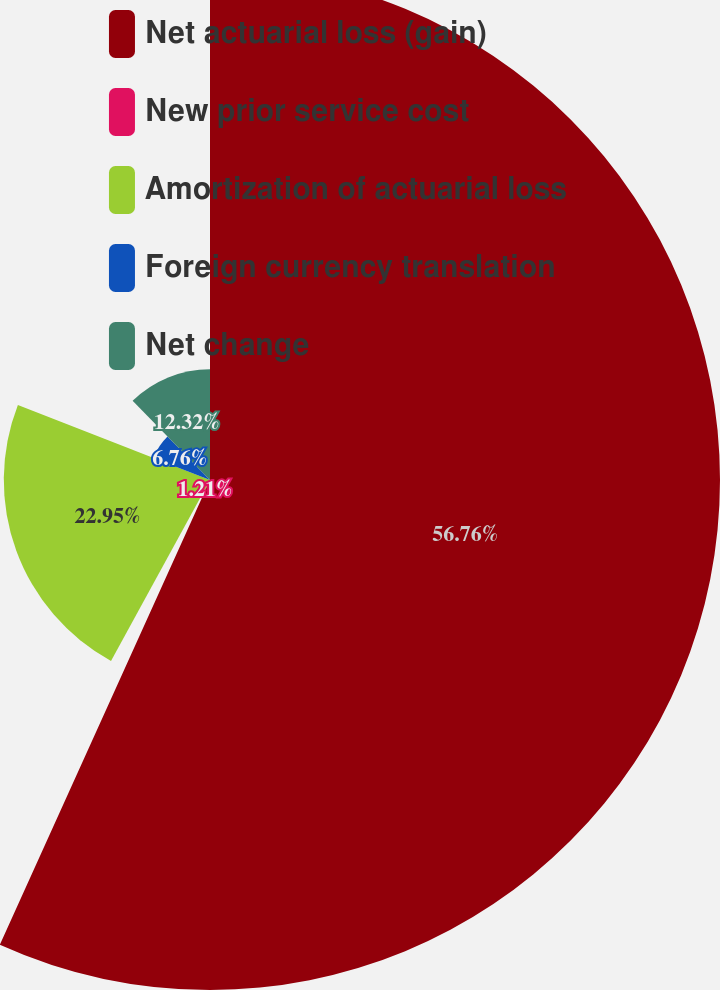Convert chart. <chart><loc_0><loc_0><loc_500><loc_500><pie_chart><fcel>Net actuarial loss (gain)<fcel>New prior service cost<fcel>Amortization of actuarial loss<fcel>Foreign currency translation<fcel>Net change<nl><fcel>56.76%<fcel>1.21%<fcel>22.95%<fcel>6.76%<fcel>12.32%<nl></chart> 